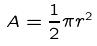<formula> <loc_0><loc_0><loc_500><loc_500>A = \frac { 1 } { 2 } \pi r ^ { 2 }</formula> 